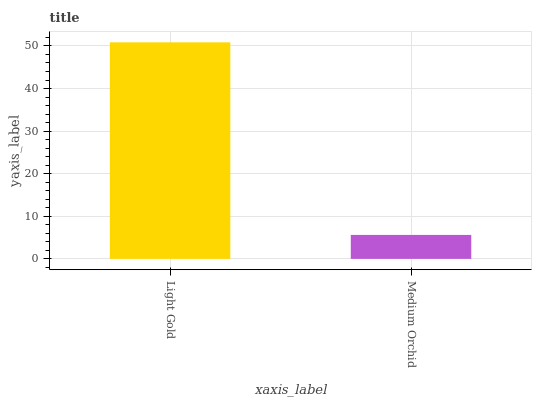Is Medium Orchid the minimum?
Answer yes or no. Yes. Is Light Gold the maximum?
Answer yes or no. Yes. Is Medium Orchid the maximum?
Answer yes or no. No. Is Light Gold greater than Medium Orchid?
Answer yes or no. Yes. Is Medium Orchid less than Light Gold?
Answer yes or no. Yes. Is Medium Orchid greater than Light Gold?
Answer yes or no. No. Is Light Gold less than Medium Orchid?
Answer yes or no. No. Is Light Gold the high median?
Answer yes or no. Yes. Is Medium Orchid the low median?
Answer yes or no. Yes. Is Medium Orchid the high median?
Answer yes or no. No. Is Light Gold the low median?
Answer yes or no. No. 